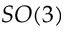<formula> <loc_0><loc_0><loc_500><loc_500>S O ( 3 )</formula> 